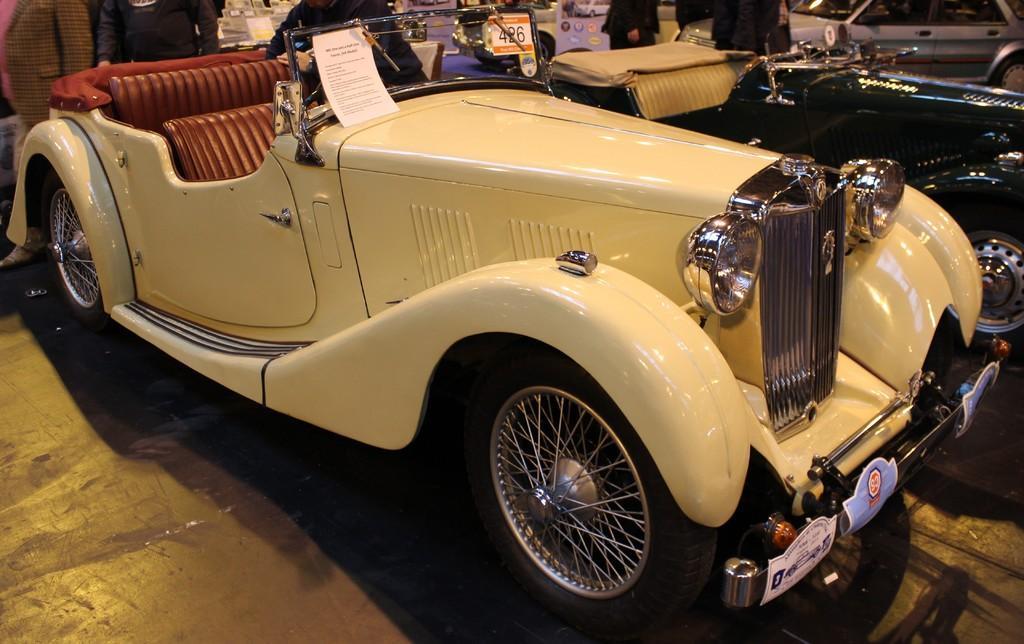Could you give a brief overview of what you see in this image? In front of the image there is a car. On top of the car there is a paper with some text on it. Beside the car there are a few other cars. There are people. In the background of the image there are some objects. At the bottom of the image there is a floor. 